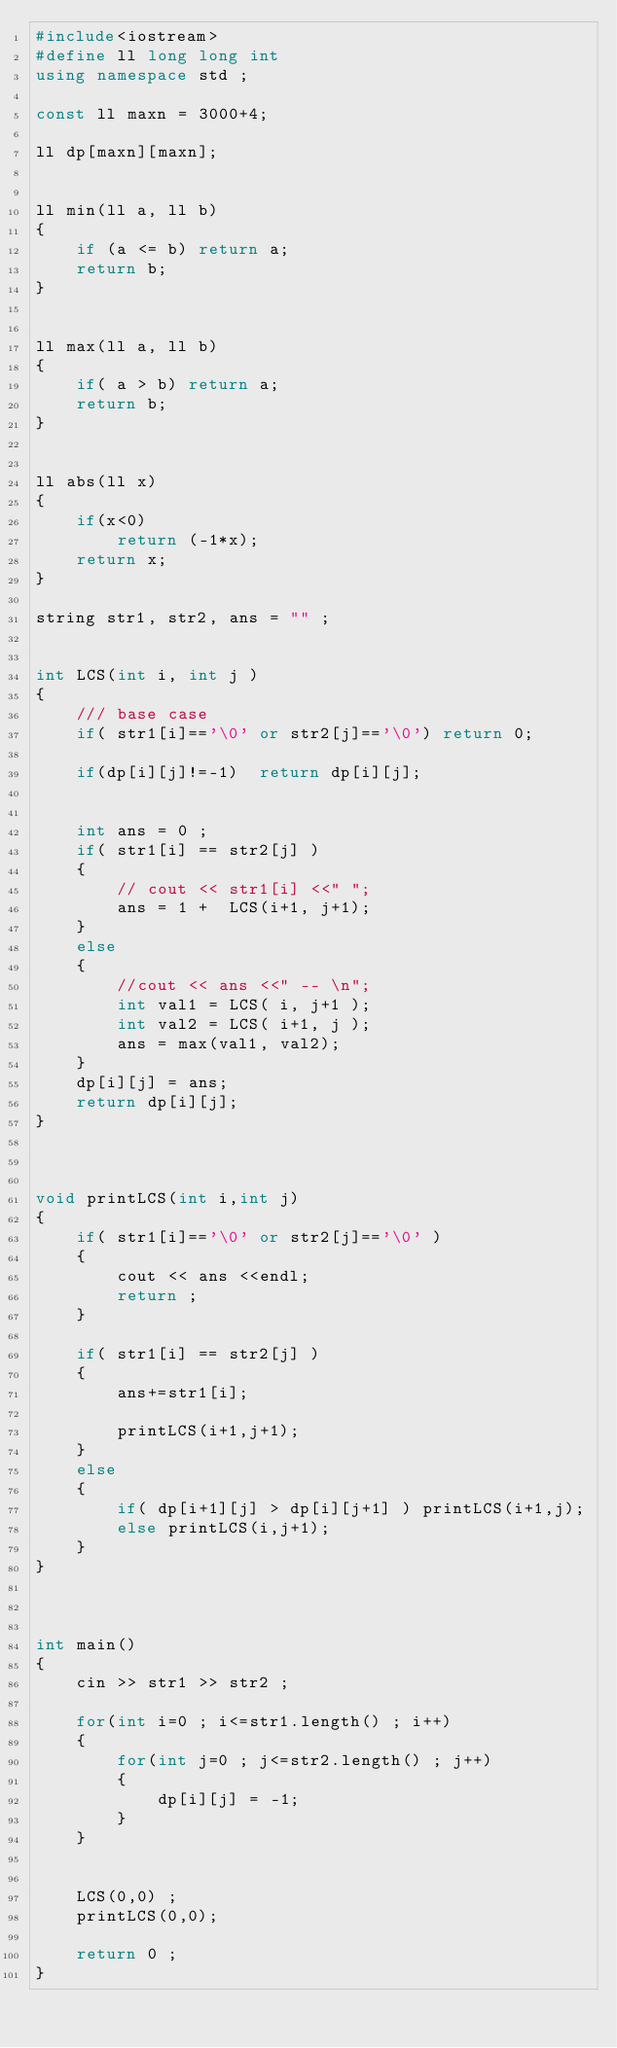Convert code to text. <code><loc_0><loc_0><loc_500><loc_500><_C++_>#include<iostream>
#define ll long long int
using namespace std ;

const ll maxn = 3000+4;

ll dp[maxn][maxn];


ll min(ll a, ll b)
{
    if (a <= b) return a;
    return b;
}


ll max(ll a, ll b)
{
    if( a > b) return a;
    return b;
}


ll abs(ll x)
{
    if(x<0)
        return (-1*x);
    return x;
}

string str1, str2, ans = "" ;


int LCS(int i, int j )
{
    /// base case
    if( str1[i]=='\0' or str2[j]=='\0') return 0;

    if(dp[i][j]!=-1)  return dp[i][j];


    int ans = 0 ;
    if( str1[i] == str2[j] )
    {
        // cout << str1[i] <<" ";
        ans = 1 +  LCS(i+1, j+1);
    }
    else
    {
        //cout << ans <<" -- \n";
        int val1 = LCS( i, j+1 );
        int val2 = LCS( i+1, j );
        ans = max(val1, val2);
    }
    dp[i][j] = ans;
    return dp[i][j];
}



void printLCS(int i,int j)
{
    if( str1[i]=='\0' or str2[j]=='\0' )
    {
        cout << ans <<endl;
        return ;
    }

    if( str1[i] == str2[j] )
    {
        ans+=str1[i];

        printLCS(i+1,j+1);
    }
    else
    {
        if( dp[i+1][j] > dp[i][j+1] ) printLCS(i+1,j);
        else printLCS(i,j+1);
    }
}



int main()
{
    cin >> str1 >> str2 ;

    for(int i=0 ; i<=str1.length() ; i++)
    {
        for(int j=0 ; j<=str2.length() ; j++)
        {
            dp[i][j] = -1;
        }
    }


    LCS(0,0) ;
    printLCS(0,0);

    return 0 ;
}
</code> 